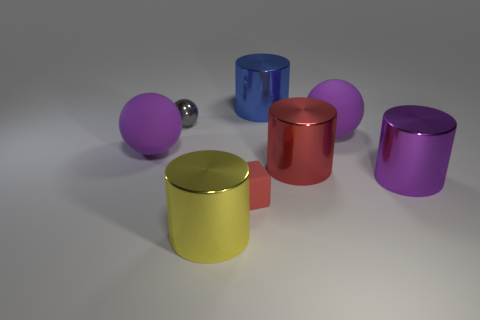The metal thing that is in front of the tiny red matte cube is what color?
Provide a succinct answer. Yellow. Do the matte sphere that is to the right of the large yellow cylinder and the metallic object that is in front of the purple metallic cylinder have the same size?
Offer a terse response. Yes. How many objects are either tiny matte things or tiny yellow matte spheres?
Your answer should be very brief. 1. What material is the red thing that is in front of the purple shiny cylinder in front of the tiny gray thing?
Provide a short and direct response. Rubber. What number of big purple matte things have the same shape as the tiny red thing?
Provide a short and direct response. 0. Is there a cylinder of the same color as the matte block?
Your answer should be very brief. Yes. What number of things are blue metallic cylinders that are behind the tiny red object or shiny things that are on the left side of the small red rubber thing?
Provide a succinct answer. 3. Is there a purple matte ball left of the red object in front of the purple shiny thing?
Make the answer very short. Yes. There is a blue object that is the same size as the yellow thing; what is its shape?
Your answer should be very brief. Cylinder. What number of things are large shiny things that are in front of the tiny rubber object or small yellow cylinders?
Make the answer very short. 1. 